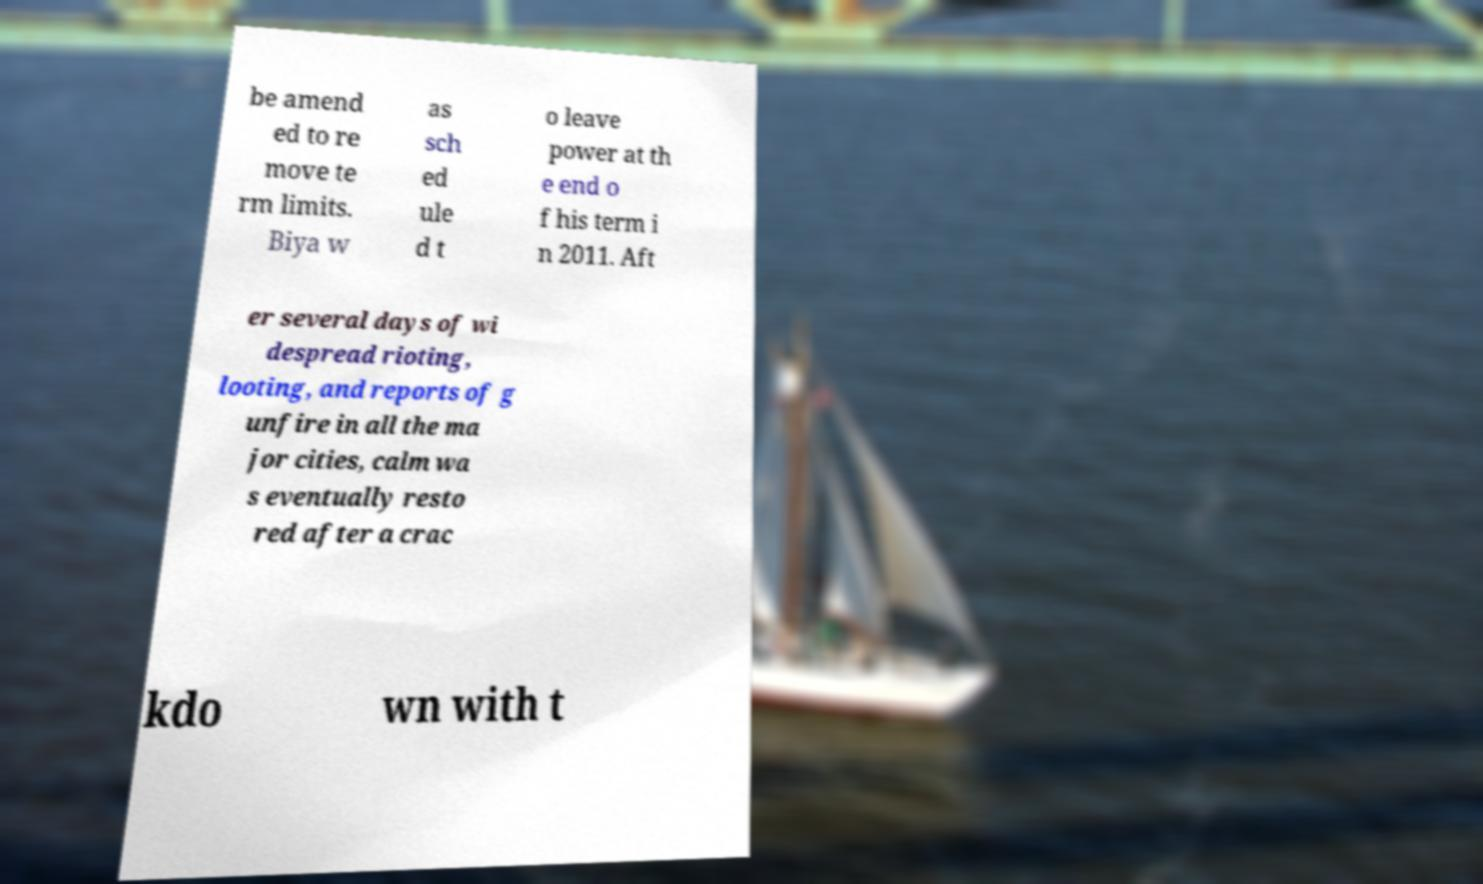For documentation purposes, I need the text within this image transcribed. Could you provide that? be amend ed to re move te rm limits. Biya w as sch ed ule d t o leave power at th e end o f his term i n 2011. Aft er several days of wi despread rioting, looting, and reports of g unfire in all the ma jor cities, calm wa s eventually resto red after a crac kdo wn with t 